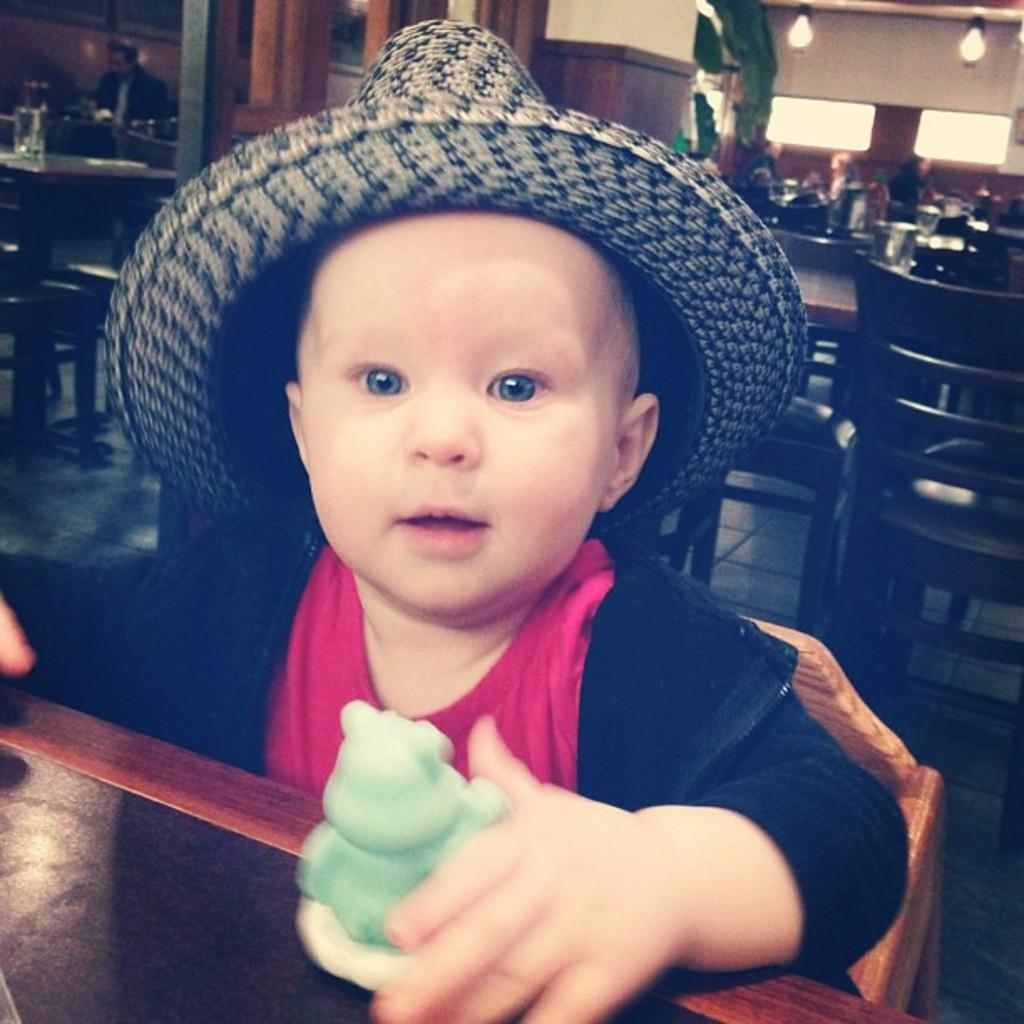What is the baby doing in the image? The baby is sitting on a chair in the image. Where is the chair located? The chair is at a table in the image. What can be seen in the background of the image? There are tables, chairs, persons, a pillar, windows, and a wall in the background of the image. What type of punishment is the baby receiving in the image? There is no indication of punishment in the image; the baby is simply sitting on a chair. What is the baby using to stir the soup in the image? There is no soup or stirring utensil present in the image. 